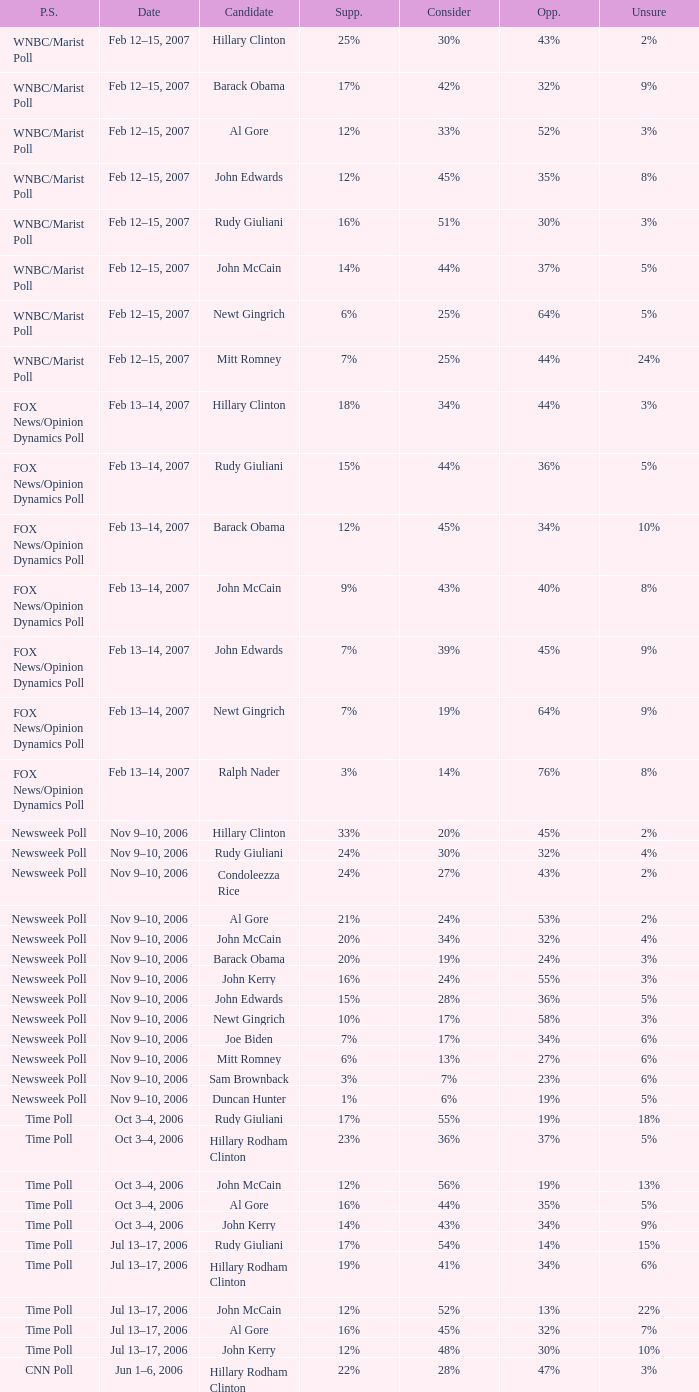What percentage of people said they would consider Rudy Giuliani as a candidate according to the Newsweek poll that showed 32% opposed him? 30%. 